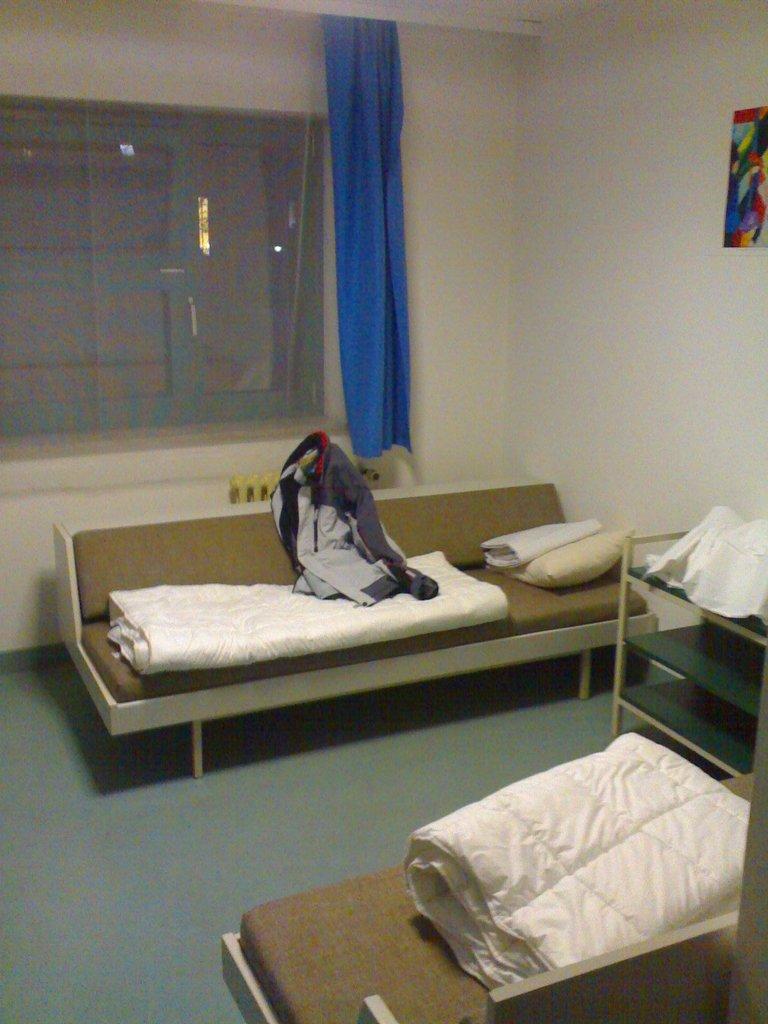Could you give a brief overview of what you see in this image? In this picture we can see there are two couches and on the couches there are blankets. On the right side of the image there is a side table and on the table there is a white cloth. There is a photo frame on the wall. On the couch there is a pillow and a jacket. Behind the couch, there is a curtain and a window. 